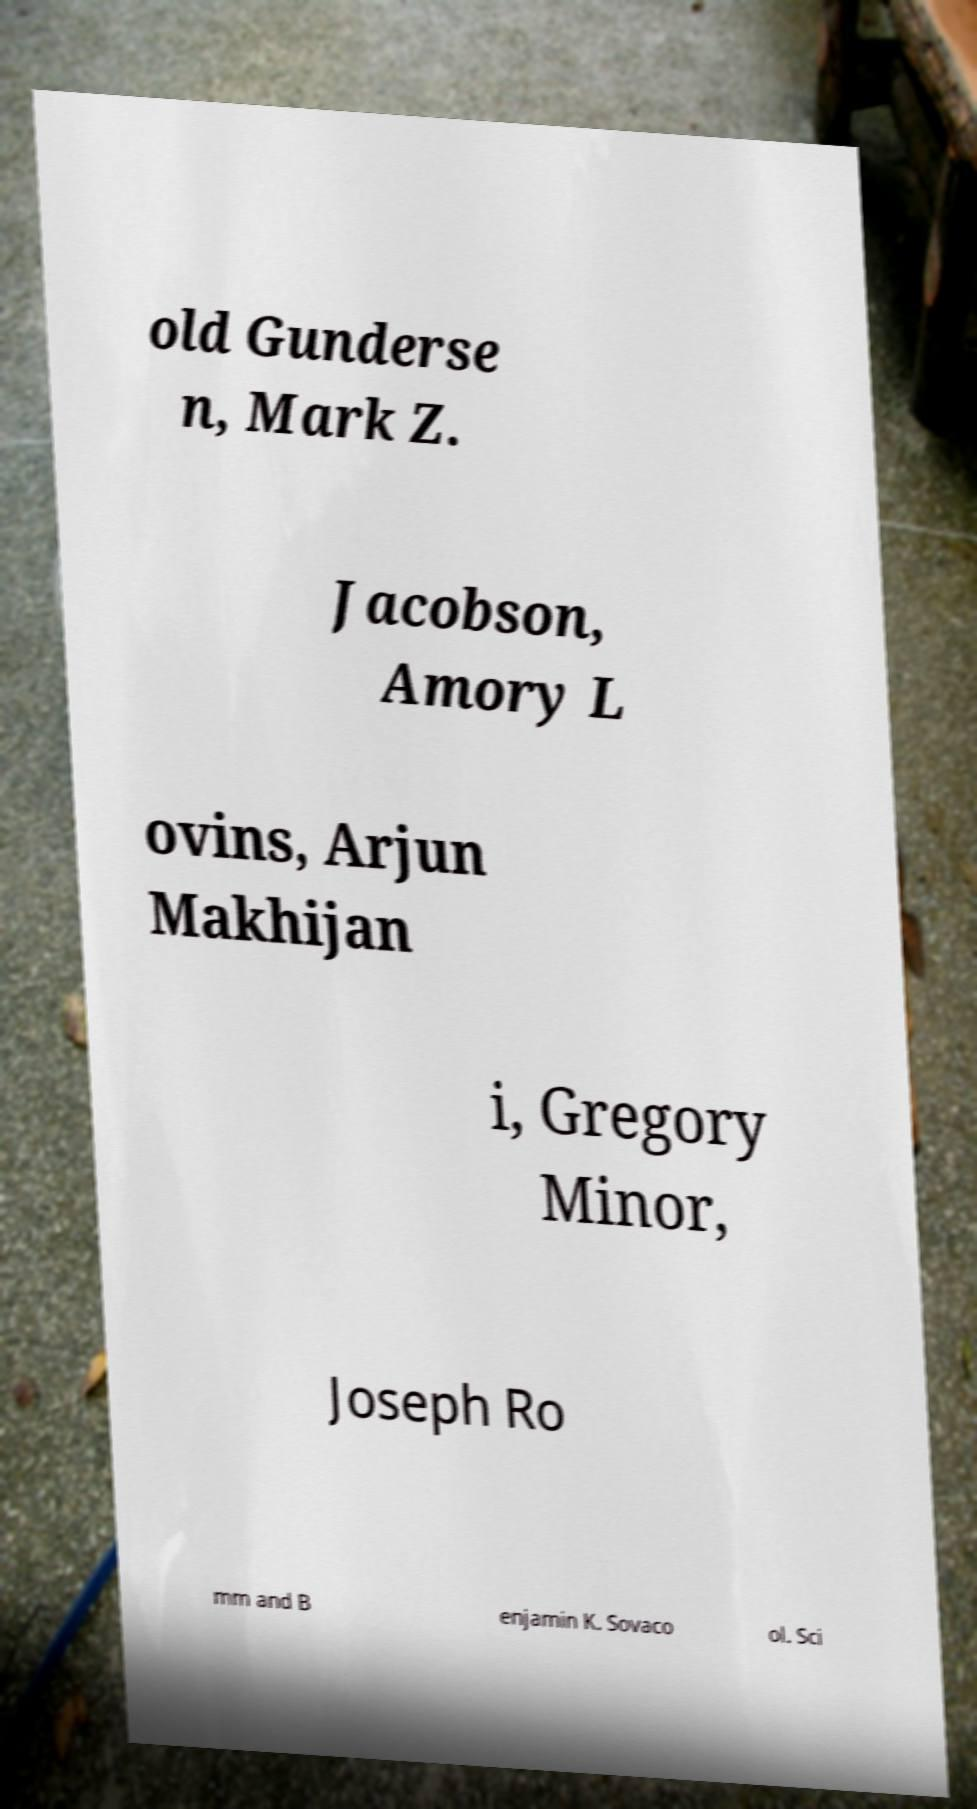There's text embedded in this image that I need extracted. Can you transcribe it verbatim? old Gunderse n, Mark Z. Jacobson, Amory L ovins, Arjun Makhijan i, Gregory Minor, Joseph Ro mm and B enjamin K. Sovaco ol. Sci 